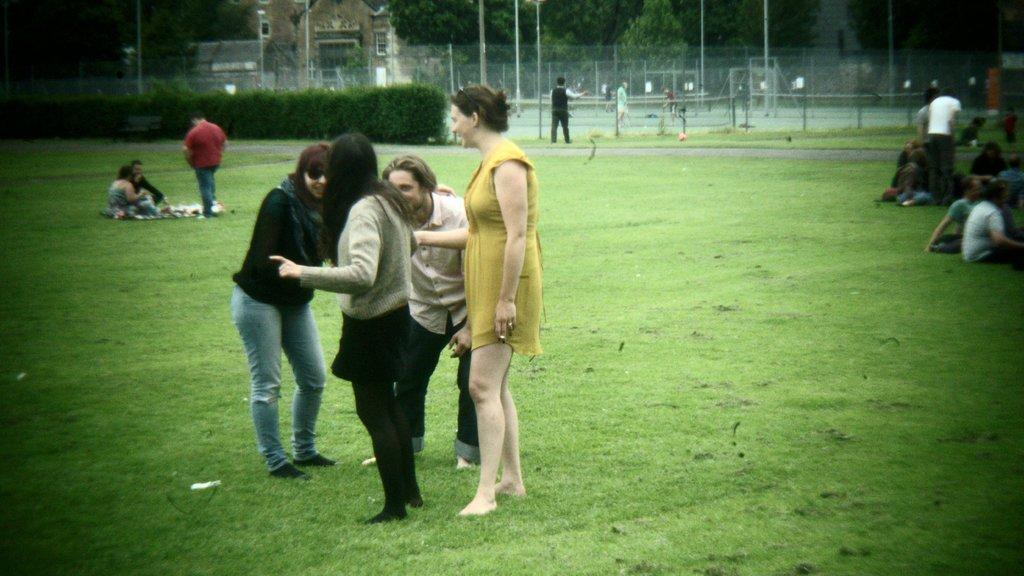What are the people in the image doing? The people in the image are standing on the grass. Can you describe the background of the image? In the background, there are people, plants, trees, poles, and a building. What type of vegetation can be seen in the background? Plants and trees are visible in the background. What architectural feature is present in the background? Poles are present in the background. What type of structure is visible in the background? There is a building in the background. What type of match is being played in the image? There is no match being played in the image; it features people standing on the grass and various elements in the background. What type of branch can be seen in the image? There is no branch present in the image. 